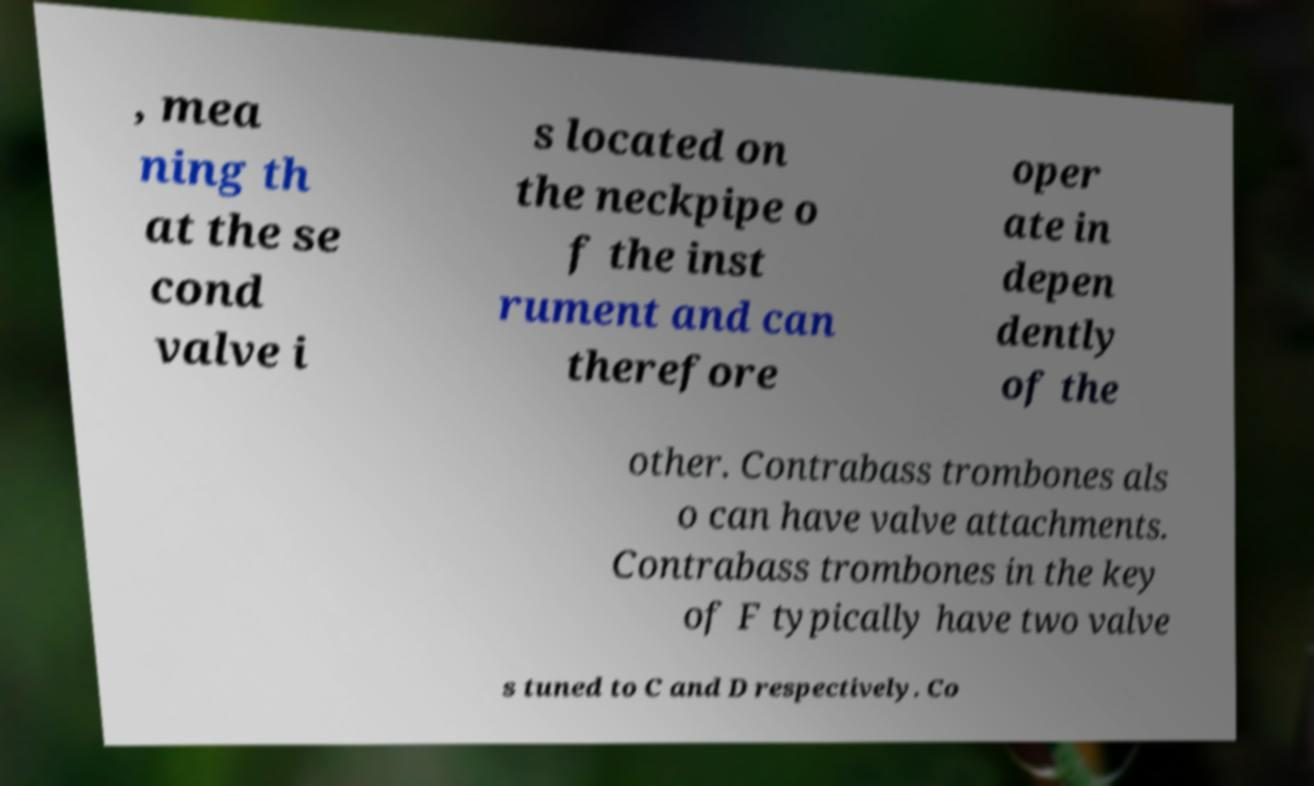I need the written content from this picture converted into text. Can you do that? , mea ning th at the se cond valve i s located on the neckpipe o f the inst rument and can therefore oper ate in depen dently of the other. Contrabass trombones als o can have valve attachments. Contrabass trombones in the key of F typically have two valve s tuned to C and D respectively. Co 